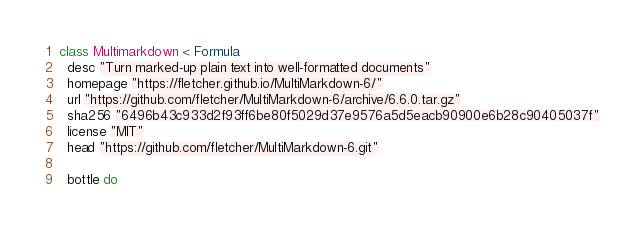Convert code to text. <code><loc_0><loc_0><loc_500><loc_500><_Ruby_>class Multimarkdown < Formula
  desc "Turn marked-up plain text into well-formatted documents"
  homepage "https://fletcher.github.io/MultiMarkdown-6/"
  url "https://github.com/fletcher/MultiMarkdown-6/archive/6.6.0.tar.gz"
  sha256 "6496b43c933d2f93ff6be80f5029d37e9576a5d5eacb90900e6b28c90405037f"
  license "MIT"
  head "https://github.com/fletcher/MultiMarkdown-6.git"

  bottle do</code> 